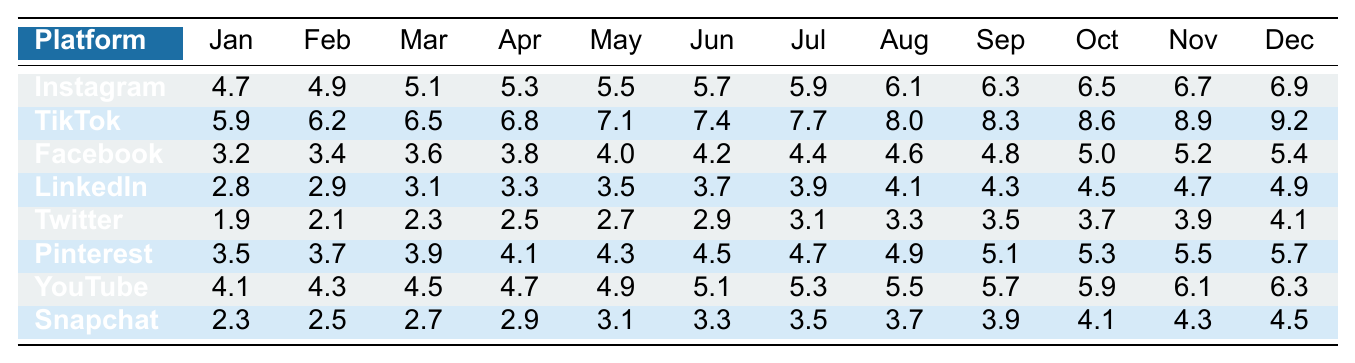What is the engagement rate for Instagram in June? The table shows that Instagram has an engagement rate of 5.7 in June.
Answer: 5.7 Which platform had the highest engagement rate in August? In August, TikTok had the highest engagement rate at 8.0, as indicated in the table.
Answer: 8.0 What was the lowest engagement rate for Twitter throughout the year? The lowest engagement rate for Twitter is 1.9, as shown in January of the table.
Answer: 1.9 What engagement rate did Snapchat achieve in November? According to the table, Snapchat's engagement rate in November is 4.1.
Answer: 4.1 Which platform had a consistent engagement rate of 5.0 or higher in the last quarter (October to December)? Checking the table, both Instagram and TikTok maintained an engagement rate of 5.0 or higher for the last quarter.
Answer: Yes How much higher was TikTok's average engagement rate compared to Facebook's throughout the year? TikTok’s average engagement rate over 12 months is calculated as (5.9 + 6.2 + 6.5 + 6.8 + 7.1 + 7.4 + 7.7 + 8.0 + 8.3 + 8.6 + 8.9 + 9.2)/12 = 7.49. Facebook’s average is (3.2 + 3.4 + 3.6 + 3.8 + 4.0 + 4.2 + 4.4 + 4.6 + 4.8 + 5.0 + 5.2 + 5.4)/12 = 4.2. The difference is 7.49 - 4.2 = 3.29.
Answer: 3.29 Which platform showed the most significant month-on-month increase in engagement rates from January to December? Analyzing the table, TikTok's engagement rate increased from 5.9 in January to 9.2 in December, showing an increase of 3.3. The engagement rate data for other platforms demonstrates lower increases over the same period.
Answer: TikTok Calculate the median engagement rate for Pinterest throughout the year. The engagement rates for Pinterest are organized from January to December: 3.5, 3.7, 3.9, 4.1, 4.3, 4.5, 4.7, 4.9, 5.1, 5.3, 5.5, 5.7. The sorted values are: 3.5, 3.7, 3.9, 4.1, 4.3, 4.5, 4.7, 4.9, 5.1, 5.3, 5.5, 5.7. As there are 12 data points, the median is the average of the 6th and 7th numbers: (4.5 + 4.7) / 2 = 4.6.
Answer: 4.6 